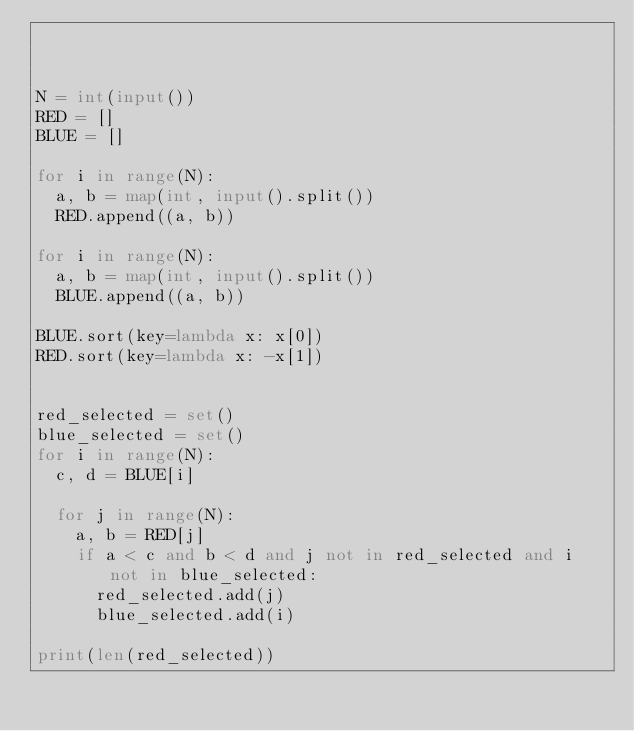<code> <loc_0><loc_0><loc_500><loc_500><_Python_>


N = int(input())
RED = []
BLUE = []

for i in range(N):
  a, b = map(int, input().split())
  RED.append((a, b))

for i in range(N):
  a, b = map(int, input().split())
  BLUE.append((a, b))

BLUE.sort(key=lambda x: x[0])
RED.sort(key=lambda x: -x[1])


red_selected = set()
blue_selected = set()
for i in range(N):
  c, d = BLUE[i]
  
  for j in range(N):
    a, b = RED[j]
    if a < c and b < d and j not in red_selected and i not in blue_selected:
      red_selected.add(j)
      blue_selected.add(i)

print(len(red_selected))</code> 